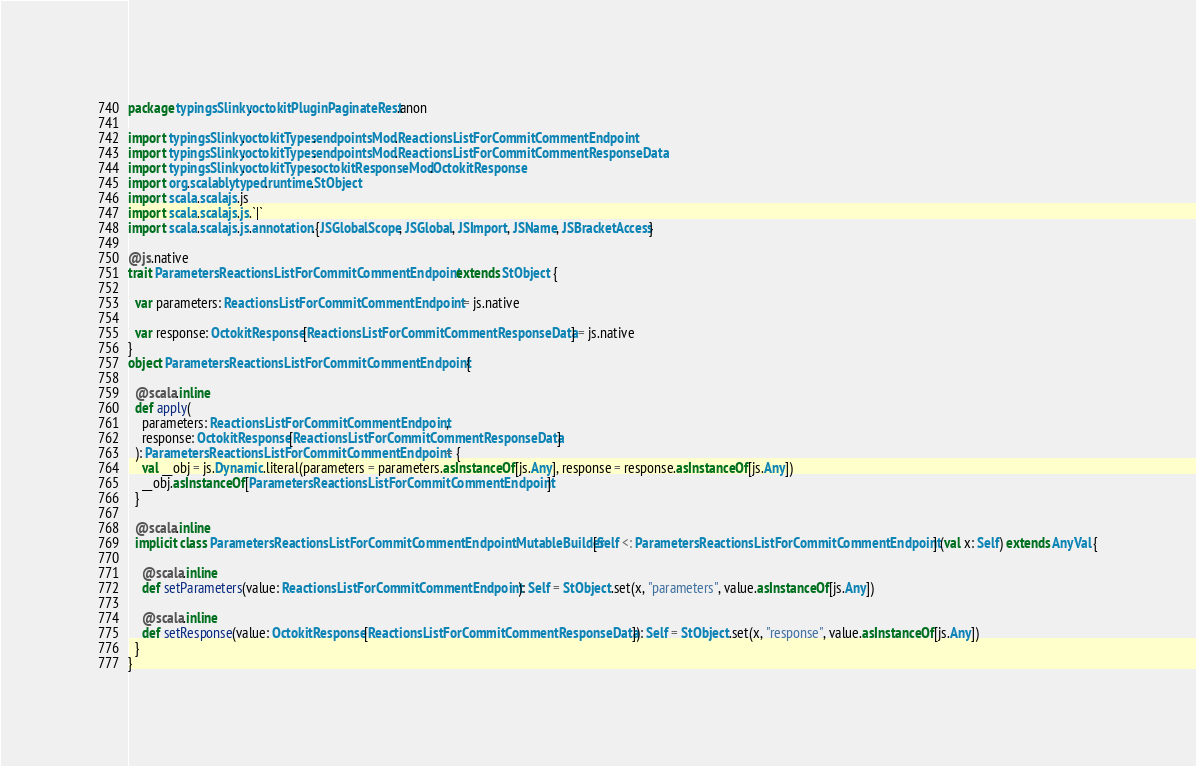<code> <loc_0><loc_0><loc_500><loc_500><_Scala_>package typingsSlinky.octokitPluginPaginateRest.anon

import typingsSlinky.octokitTypes.endpointsMod.ReactionsListForCommitCommentEndpoint
import typingsSlinky.octokitTypes.endpointsMod.ReactionsListForCommitCommentResponseData
import typingsSlinky.octokitTypes.octokitResponseMod.OctokitResponse
import org.scalablytyped.runtime.StObject
import scala.scalajs.js
import scala.scalajs.js.`|`
import scala.scalajs.js.annotation.{JSGlobalScope, JSGlobal, JSImport, JSName, JSBracketAccess}

@js.native
trait ParametersReactionsListForCommitCommentEndpoint extends StObject {
  
  var parameters: ReactionsListForCommitCommentEndpoint = js.native
  
  var response: OctokitResponse[ReactionsListForCommitCommentResponseData] = js.native
}
object ParametersReactionsListForCommitCommentEndpoint {
  
  @scala.inline
  def apply(
    parameters: ReactionsListForCommitCommentEndpoint,
    response: OctokitResponse[ReactionsListForCommitCommentResponseData]
  ): ParametersReactionsListForCommitCommentEndpoint = {
    val __obj = js.Dynamic.literal(parameters = parameters.asInstanceOf[js.Any], response = response.asInstanceOf[js.Any])
    __obj.asInstanceOf[ParametersReactionsListForCommitCommentEndpoint]
  }
  
  @scala.inline
  implicit class ParametersReactionsListForCommitCommentEndpointMutableBuilder[Self <: ParametersReactionsListForCommitCommentEndpoint] (val x: Self) extends AnyVal {
    
    @scala.inline
    def setParameters(value: ReactionsListForCommitCommentEndpoint): Self = StObject.set(x, "parameters", value.asInstanceOf[js.Any])
    
    @scala.inline
    def setResponse(value: OctokitResponse[ReactionsListForCommitCommentResponseData]): Self = StObject.set(x, "response", value.asInstanceOf[js.Any])
  }
}
</code> 